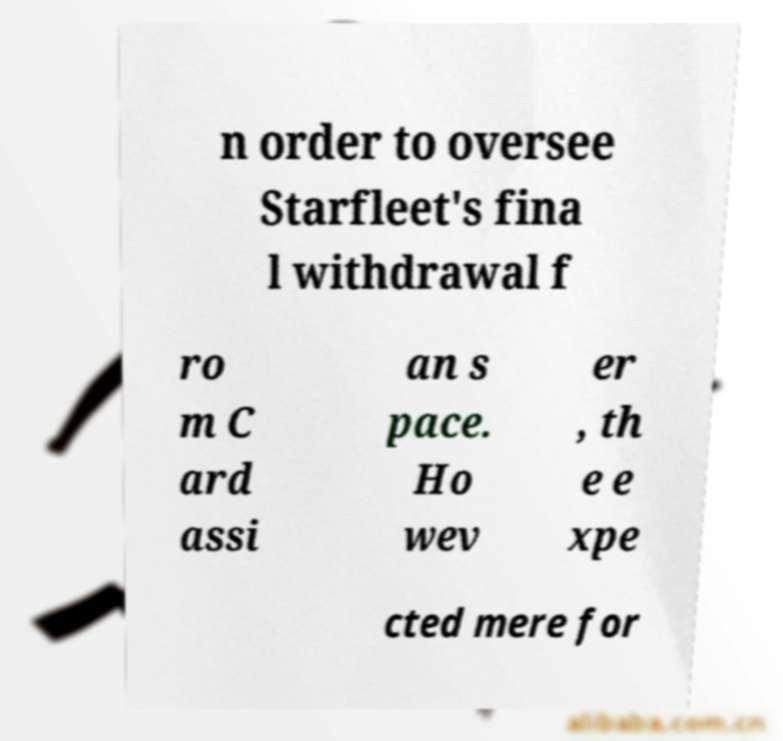Could you extract and type out the text from this image? n order to oversee Starfleet's fina l withdrawal f ro m C ard assi an s pace. Ho wev er , th e e xpe cted mere for 